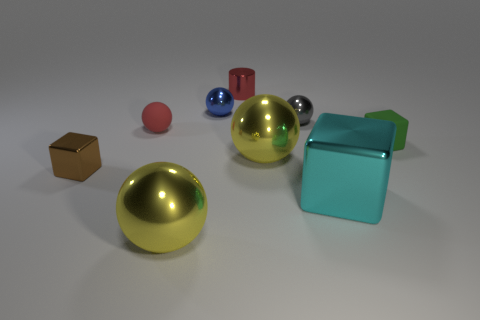Subtract all blue balls. How many balls are left? 4 Subtract all blue spheres. How many spheres are left? 4 Subtract all cyan spheres. Subtract all green blocks. How many spheres are left? 5 Add 1 purple balls. How many objects exist? 10 Subtract all balls. How many objects are left? 4 Add 1 big shiny spheres. How many big shiny spheres are left? 3 Add 1 tiny red objects. How many tiny red objects exist? 3 Subtract 0 green balls. How many objects are left? 9 Subtract all matte cylinders. Subtract all red metal cylinders. How many objects are left? 8 